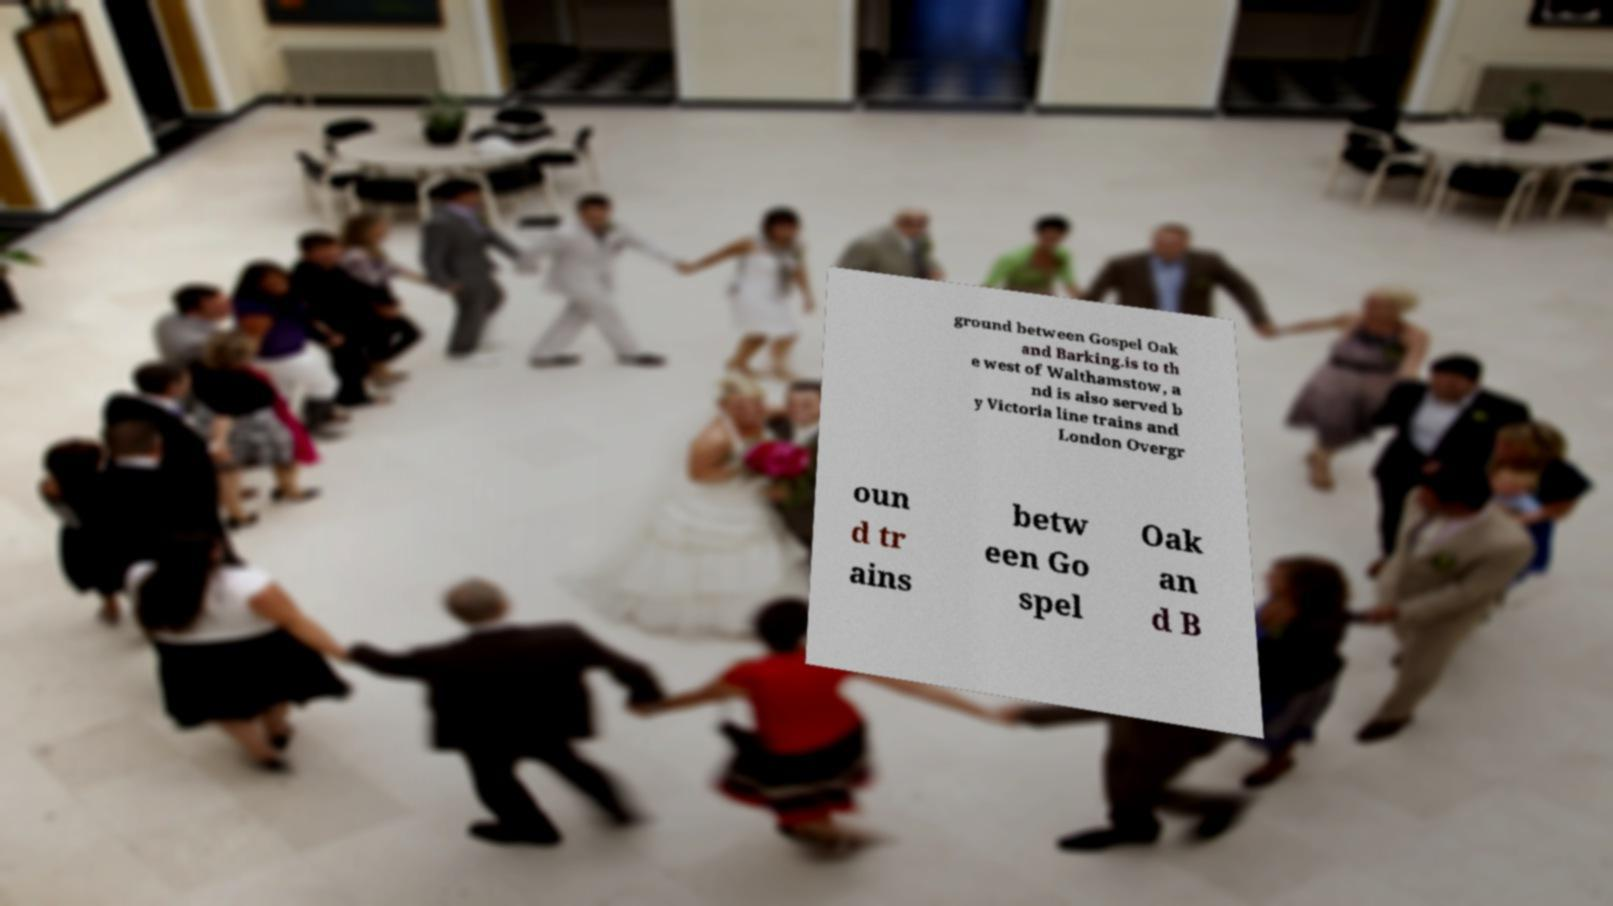There's text embedded in this image that I need extracted. Can you transcribe it verbatim? ground between Gospel Oak and Barking.is to th e west of Walthamstow, a nd is also served b y Victoria line trains and London Overgr oun d tr ains betw een Go spel Oak an d B 